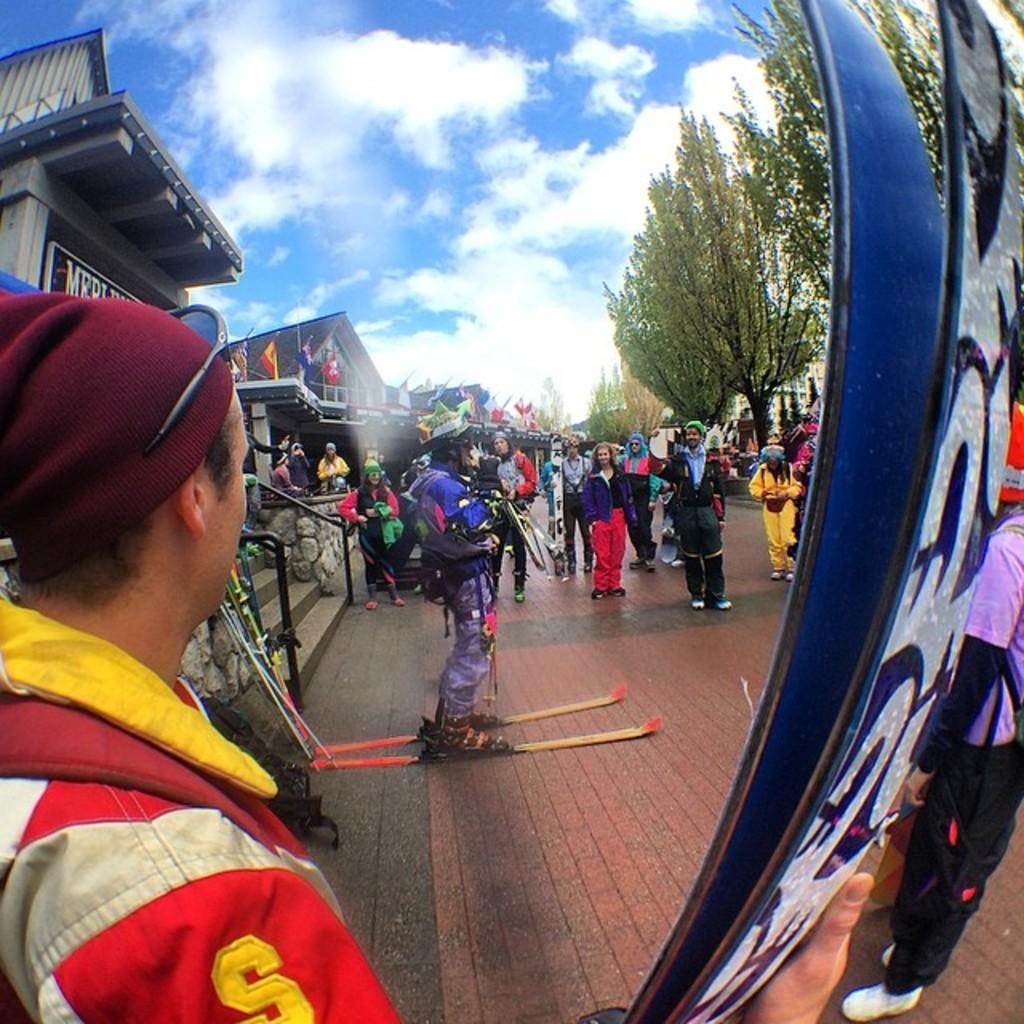<image>
Create a compact narrative representing the image presented. A man has the letter S on the arm of his jacket. 